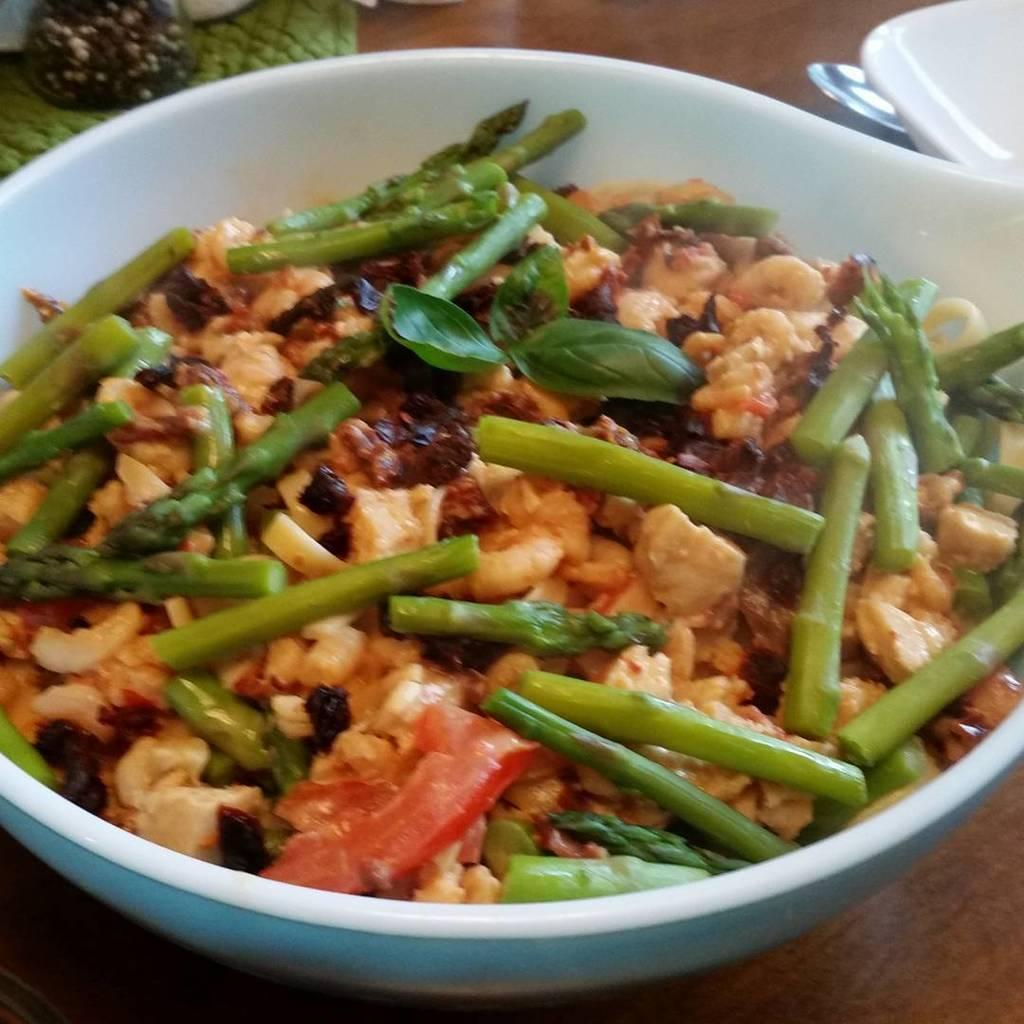What is in the serving bowl that is visible in the image? The serving bowl contains food. Where is the serving bowl located in the image? The serving bowl is placed on a table. What advice does the dad give about the food in the serving bowl in the image? There is no dad present in the image, nor is there any advice being given. 